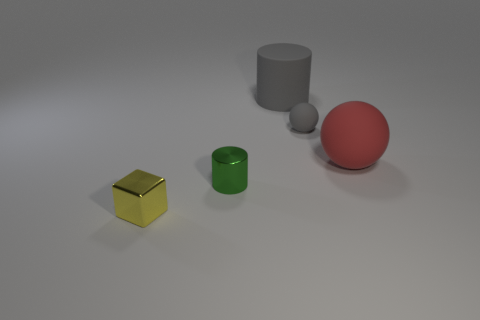Add 4 small yellow blocks. How many objects exist? 9 Subtract all spheres. How many objects are left? 3 Add 3 green objects. How many green objects are left? 4 Add 1 large cylinders. How many large cylinders exist? 2 Subtract 0 blue cylinders. How many objects are left? 5 Subtract all brown shiny cylinders. Subtract all matte cylinders. How many objects are left? 4 